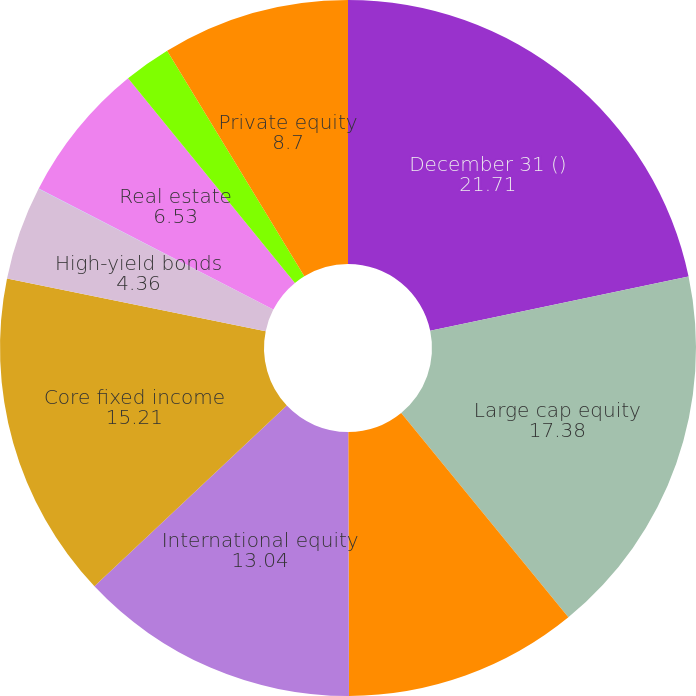Convert chart. <chart><loc_0><loc_0><loc_500><loc_500><pie_chart><fcel>December 31 ()<fcel>Large cap equity<fcel>Small cap equity<fcel>International equity<fcel>Core fixed income<fcel>High-yield bonds<fcel>Emerging markets<fcel>Real estate<fcel>Hedge funds<fcel>Private equity<nl><fcel>21.71%<fcel>17.38%<fcel>10.87%<fcel>13.04%<fcel>15.21%<fcel>4.36%<fcel>0.02%<fcel>6.53%<fcel>2.19%<fcel>8.7%<nl></chart> 